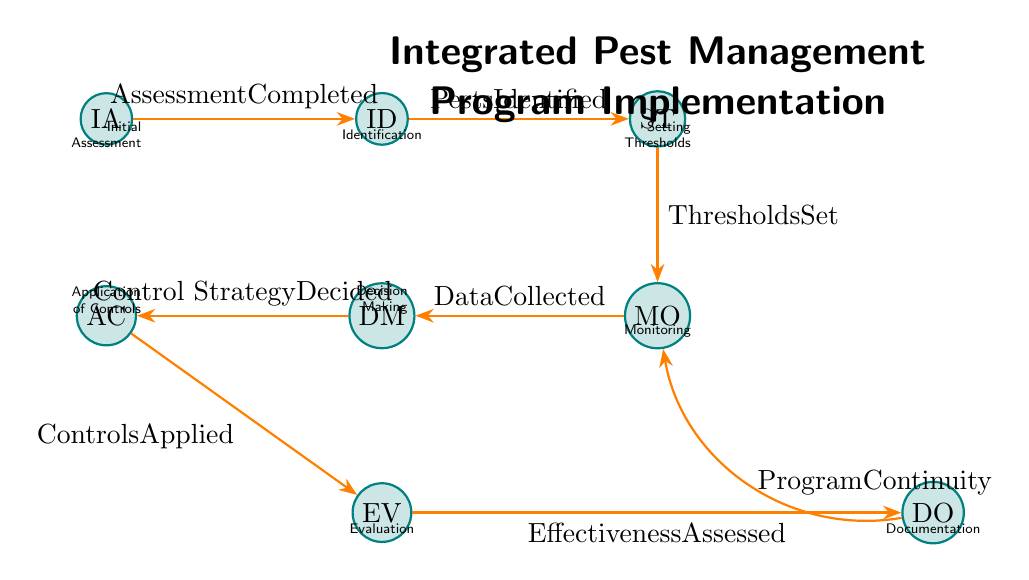What is the first state in the diagram? The first state is labeled as "InitialAssessment", which is the starting point of the Finite State Machine.
Answer: InitialAssessment How many states are present in the diagram? The diagram includes eight states outlined, which can be counted directly from the visual representation.
Answer: Eight What is the condition for moving from Monitoring to DecisionMaking? The transition from Monitoring to DecisionMaking requires the condition to be "DataCollected", as indicated on the edge connecting the two nodes.
Answer: DataCollected Which state follows Identification? After Identification, the next state is SettingThresholds, based on the transition indicated in the diagram.
Answer: SettingThresholds Which state does not have an outgoing transition back to an earlier state? Evaluation does not have an outgoing transition back, as it leads directly to Documentation without returning to a previous step.
Answer: Evaluation What are the applied control strategies based on in the DecisionMaking state? The control strategies in the DecisionMaking state are based on monitoring data and established thresholds, requiring an understanding of both previous states to answer this.
Answer: Monitoring data and thresholds How is the transition from Documentation to Monitoring described? The transition from Documentation to Monitoring is described by the condition "ProgramContinuity", indicating that the ongoing program is cyclically monitored.
Answer: ProgramContinuity What is the last state in the implementation process? The last state in the implementation process is Documentation, which indicates the final stage before potentially returning to Monitoring for continuous evaluation.
Answer: Documentation Explain the path after controls are applied. After the controls are applied in the ApplicationOfControls state, the system transitions to Evaluation, where the effectiveness of those controls is assessed before moving to Documentation for record-keeping.
Answer: Evaluation 